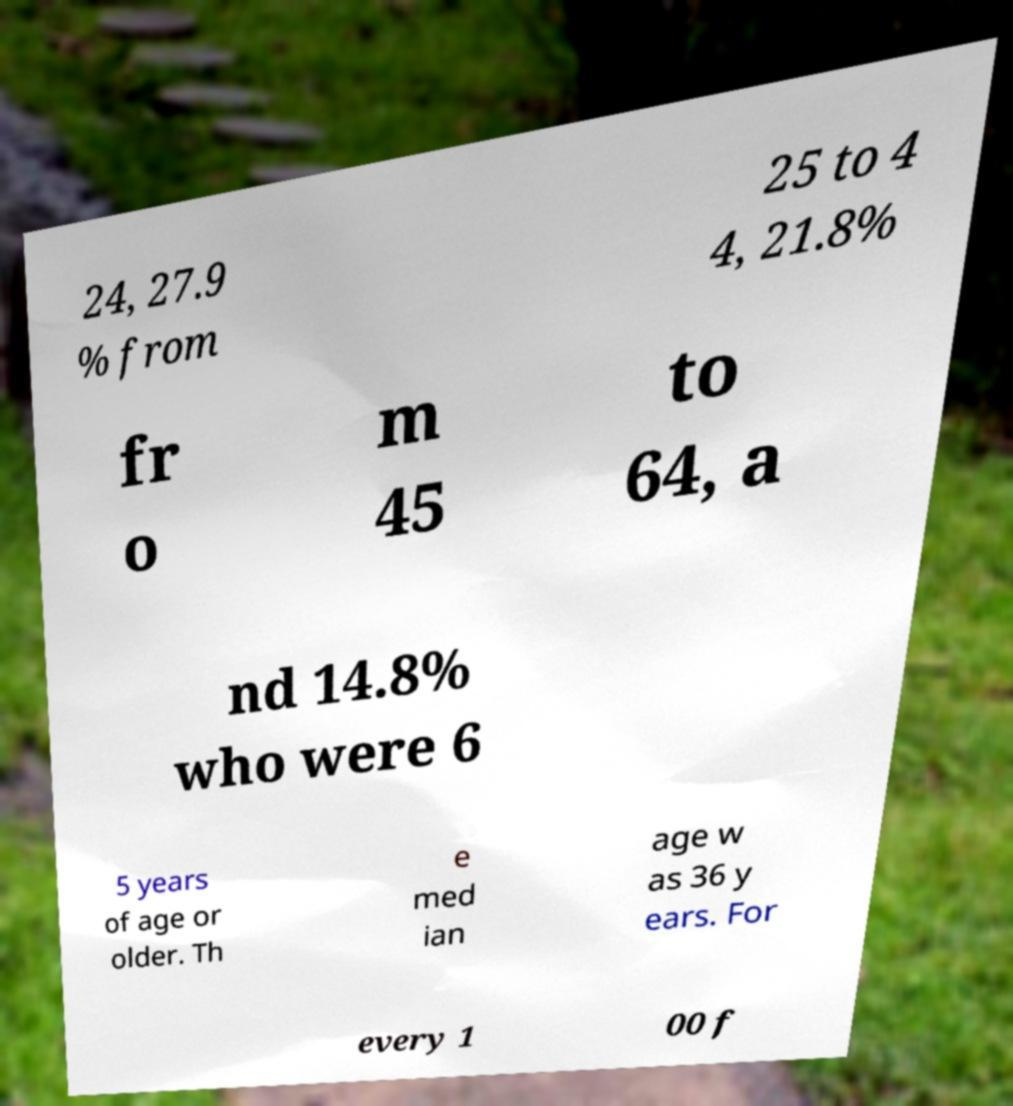I need the written content from this picture converted into text. Can you do that? 24, 27.9 % from 25 to 4 4, 21.8% fr o m 45 to 64, a nd 14.8% who were 6 5 years of age or older. Th e med ian age w as 36 y ears. For every 1 00 f 